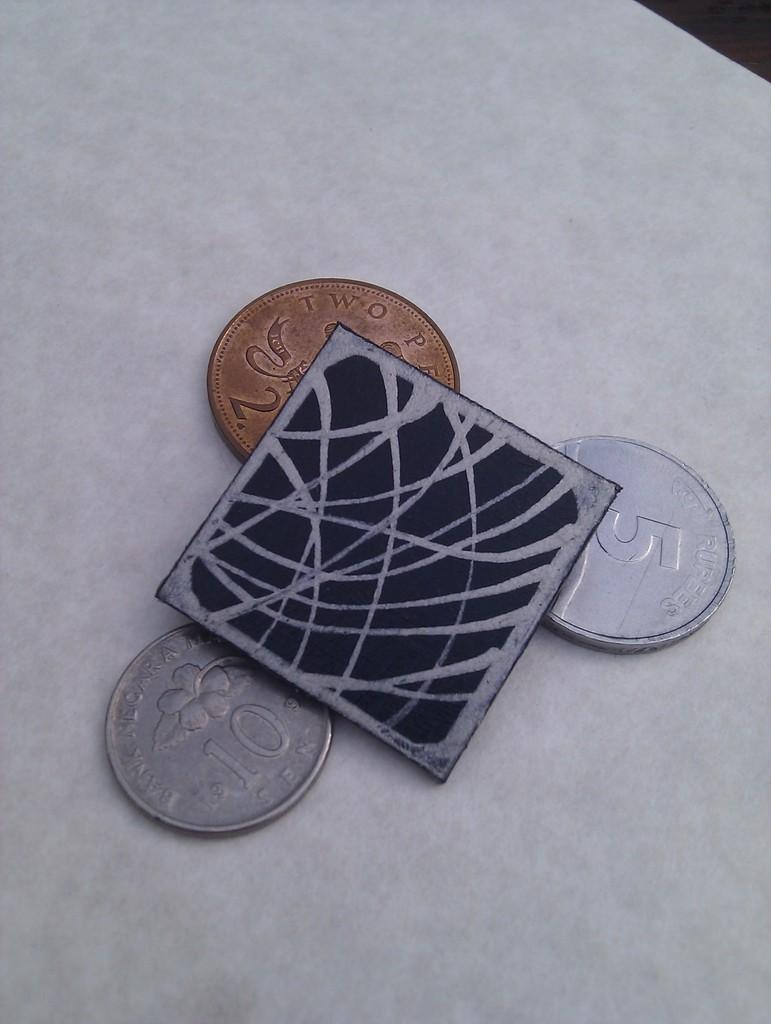<image>
Give a short and clear explanation of the subsequent image. Three coins are partially hidden under a square; the silver coins are denominations of 5 and 10. 